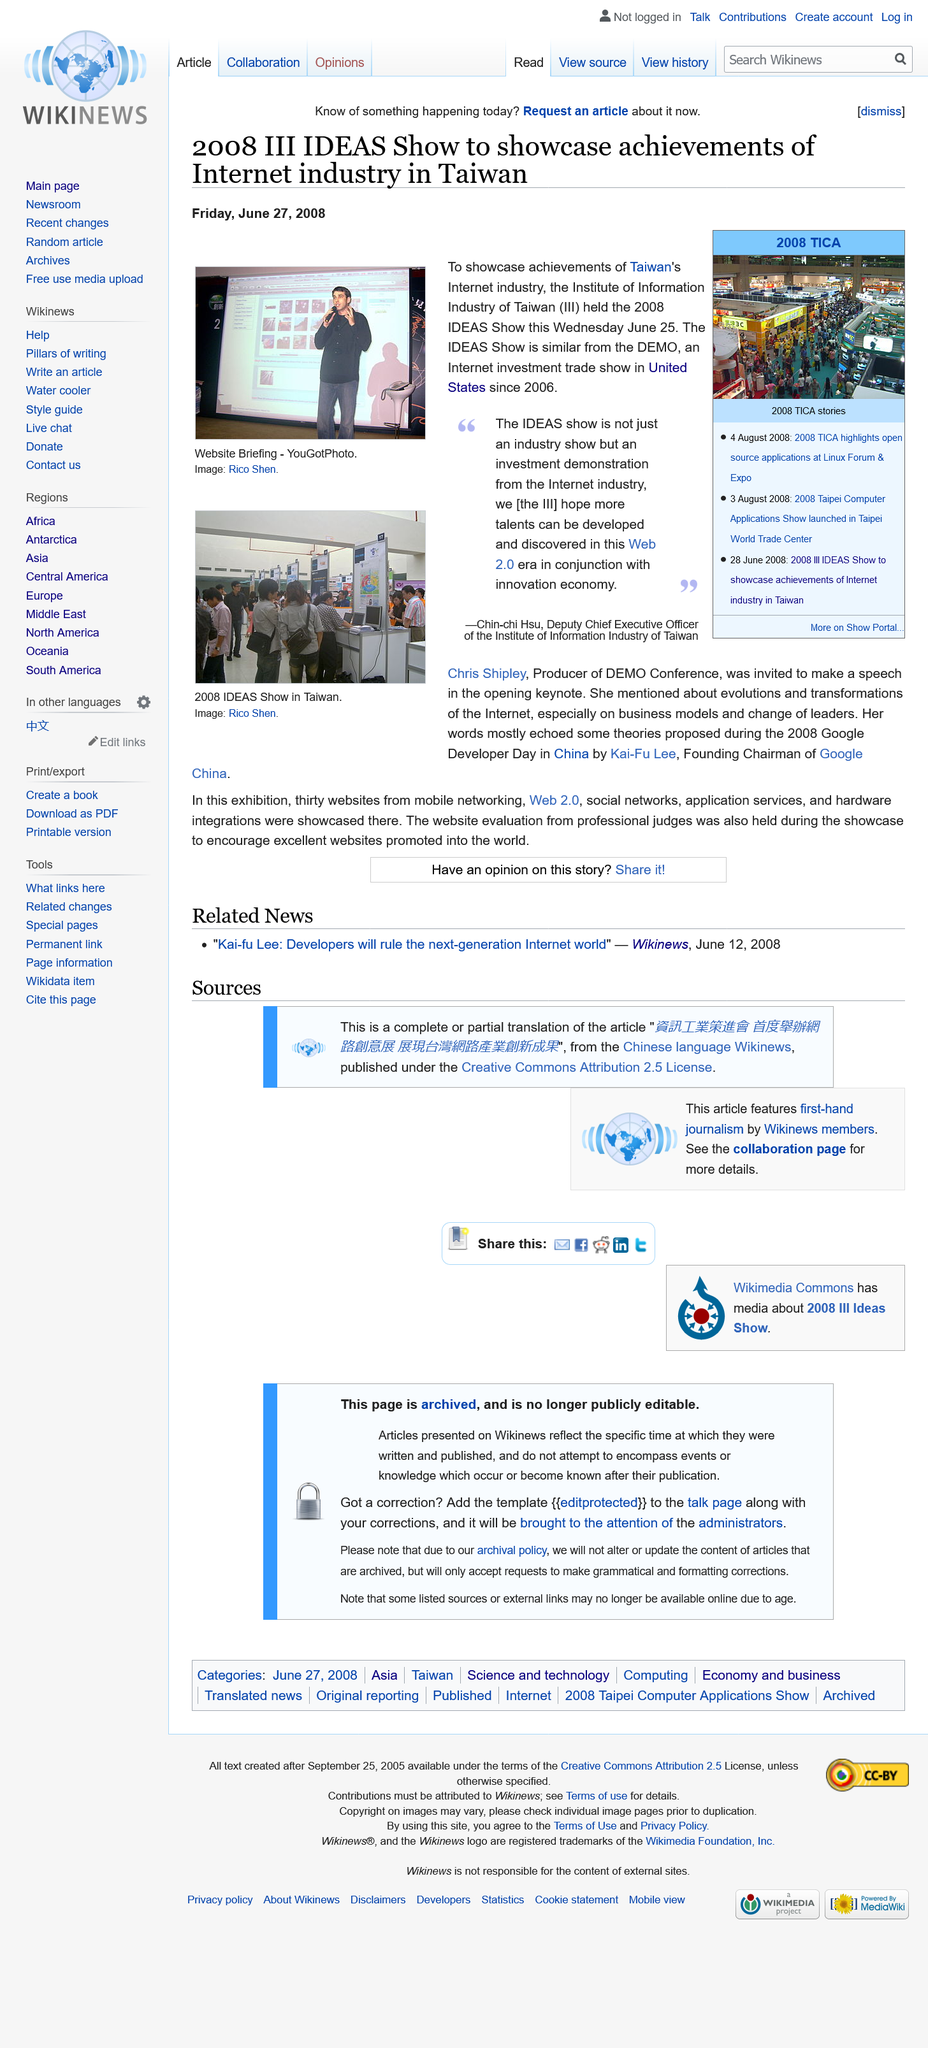Give some essential details in this illustration. The 2008 IDEAS show took place on Wednesday, June 25, 2008. It has been stated that the IDEAS show is not just an industry show, but rather a multifaceted event, as claimed by Chin-Chi Hsu. Chin-Chi Hsu holds the position of Deputy Chief Executive Officer. 